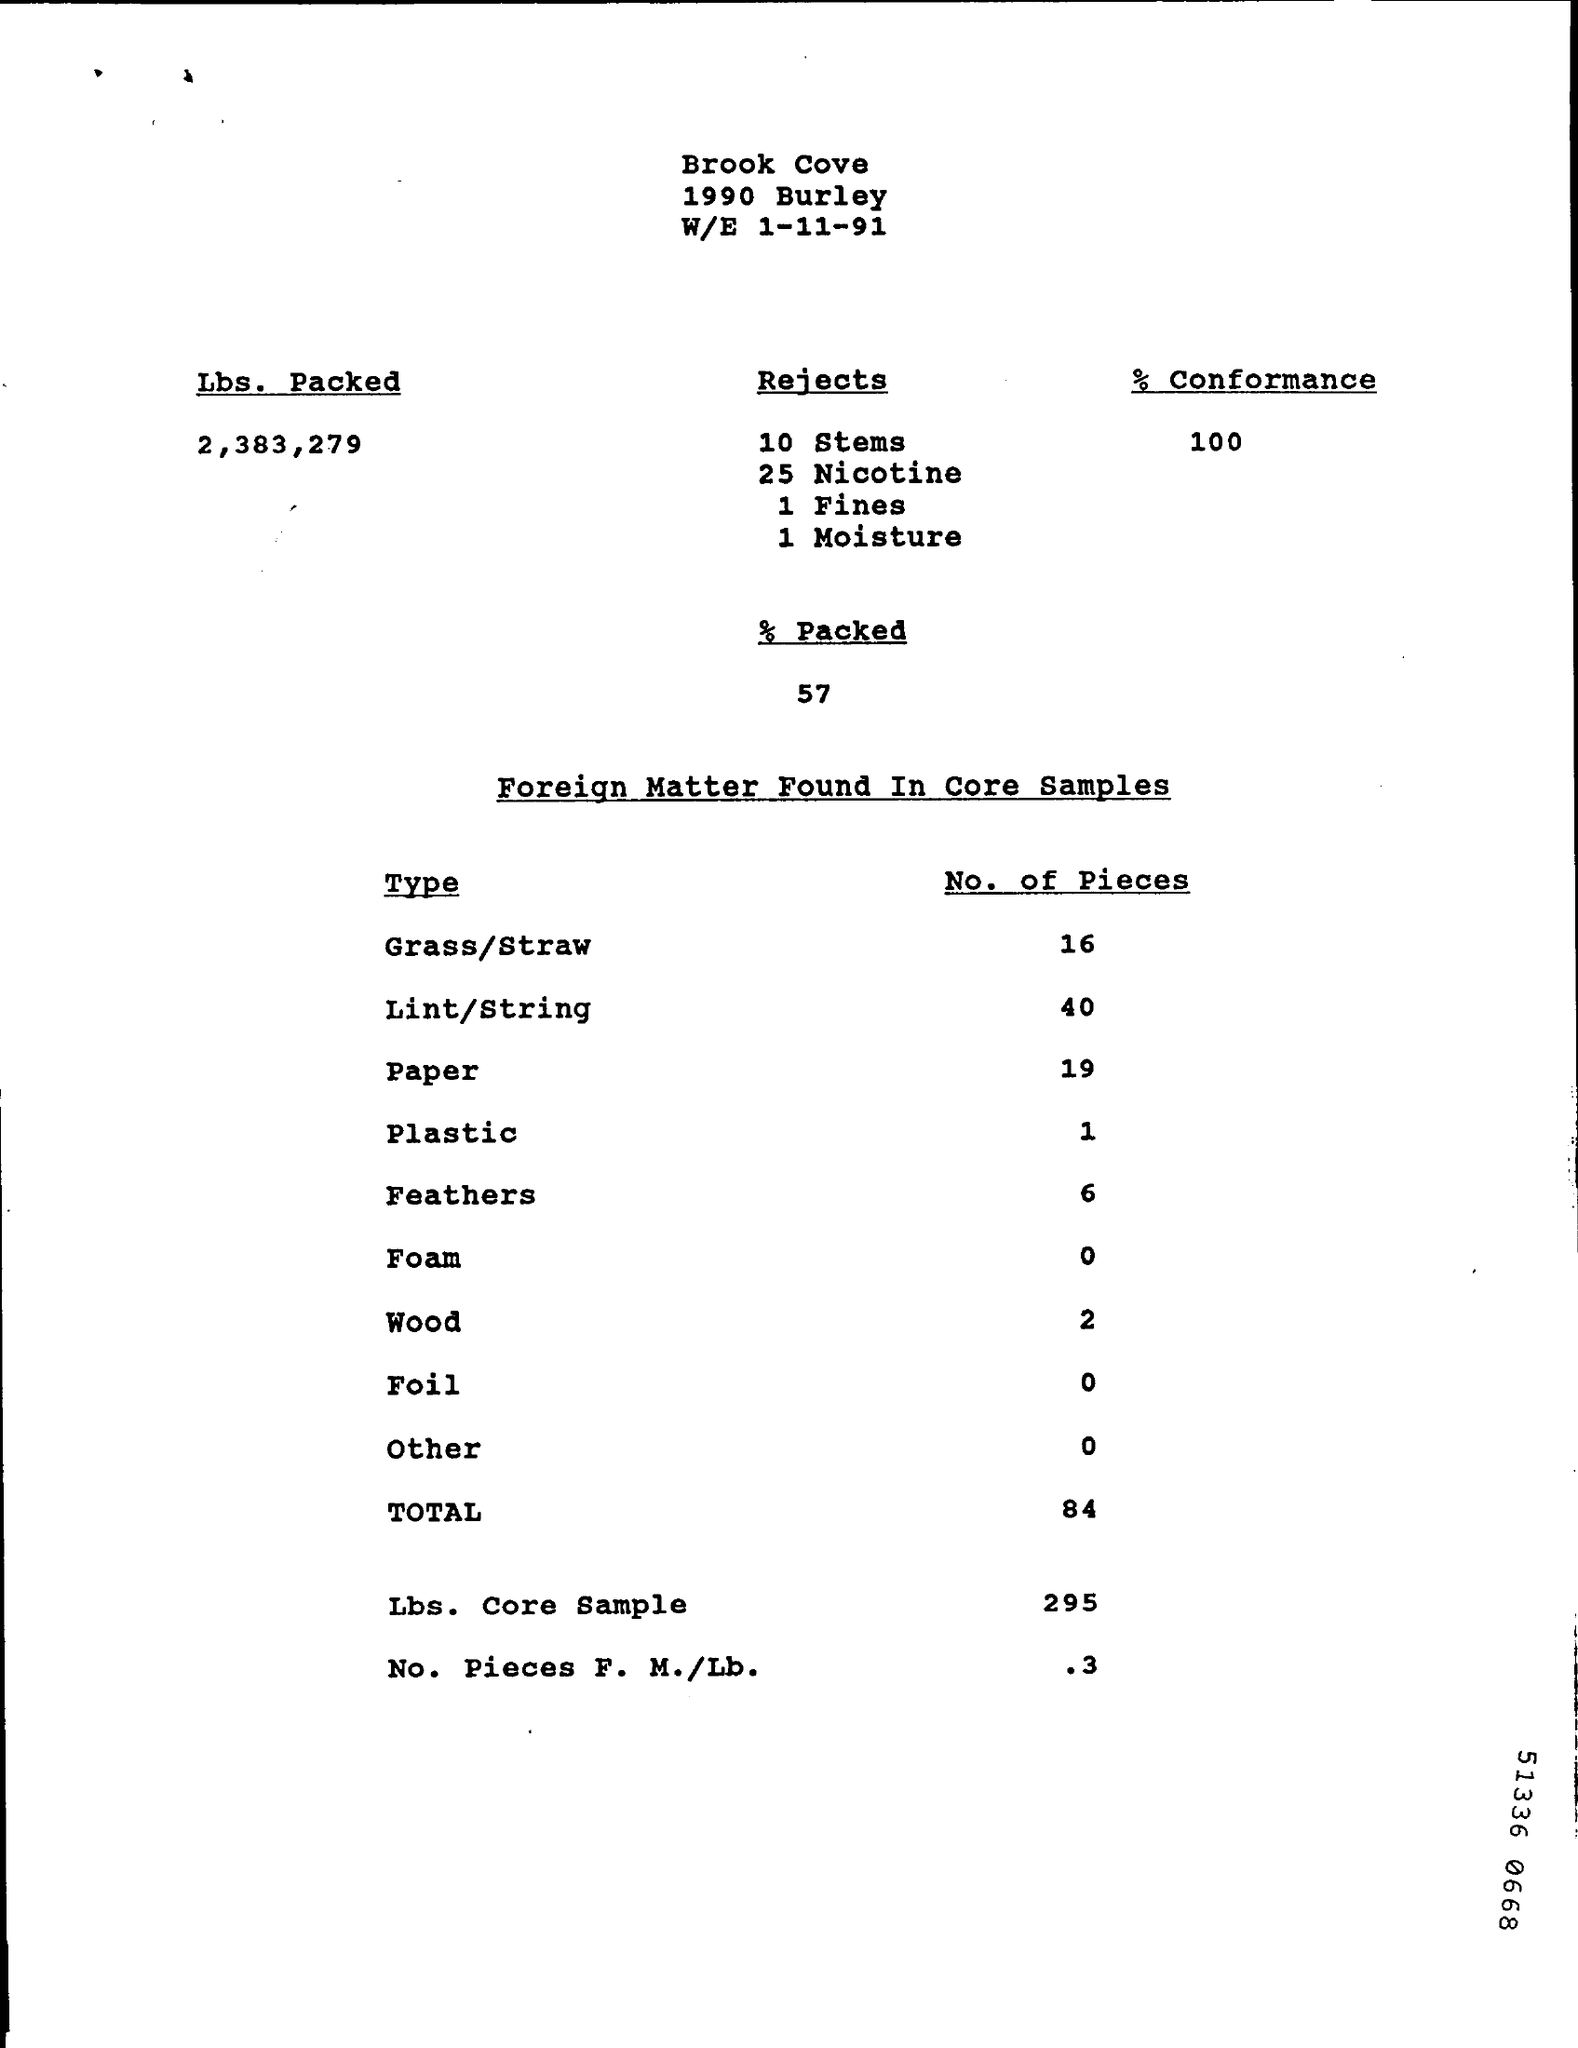Out of total Lbs. Packed, how many stems were rejected?
Provide a short and direct response. 10 stems. How many feathers were found in the samples?
Your answer should be very brief. 6. 